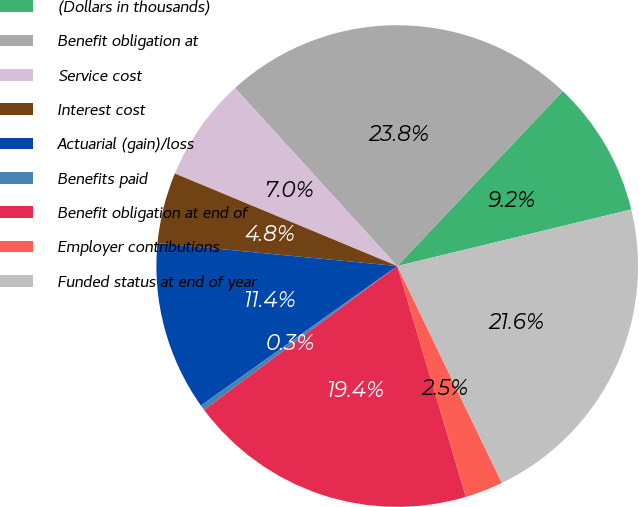Convert chart. <chart><loc_0><loc_0><loc_500><loc_500><pie_chart><fcel>(Dollars in thousands)<fcel>Benefit obligation at<fcel>Service cost<fcel>Interest cost<fcel>Actuarial (gain)/loss<fcel>Benefits paid<fcel>Benefit obligation at end of<fcel>Employer contributions<fcel>Funded status at end of year<nl><fcel>9.16%<fcel>23.83%<fcel>6.96%<fcel>4.75%<fcel>11.36%<fcel>0.35%<fcel>19.42%<fcel>2.55%<fcel>21.62%<nl></chart> 